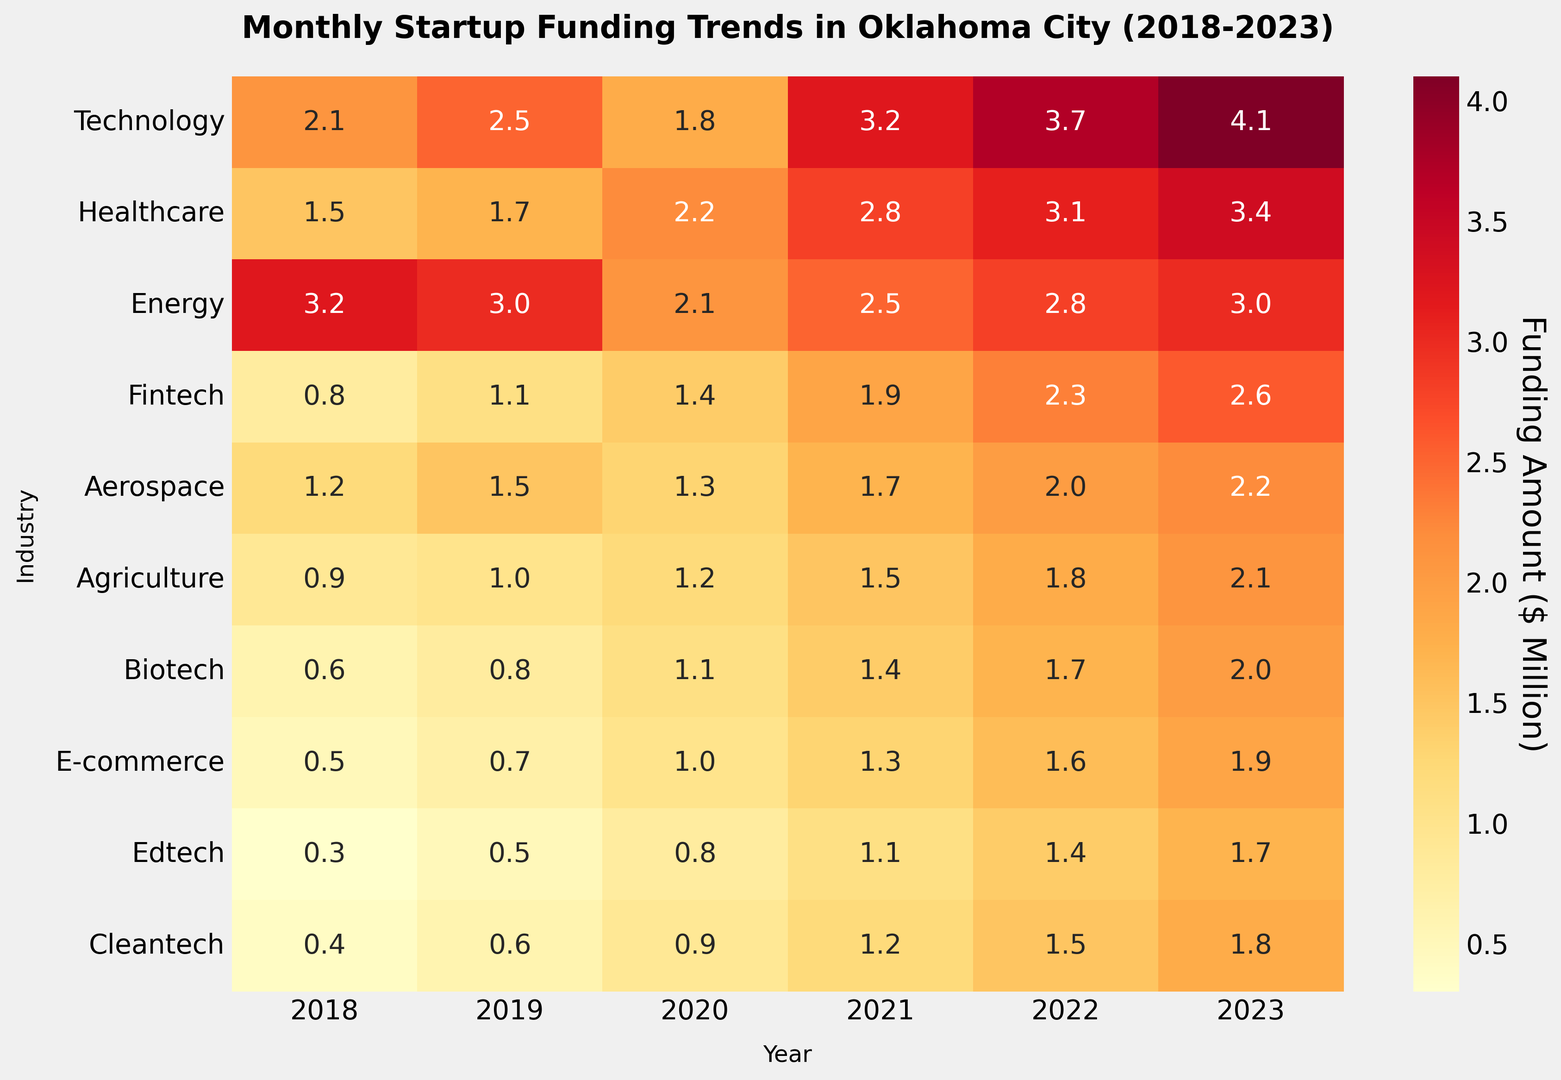What's the trend in funding for the Technology industry from 2018 to 2023? The Technology industry's funding increases over the years from 2.1 million in 2018 to 4.1 million in 2023. The heatmap has increasingly darker shades of red, indicating higher values.
Answer: An increasing trend Which industry showed the most significant growth in funding from 2018 to 2023? Compare the difference in funding for each industry from 2018 to 2023. The Technology industry leads with 4.1 - 2.1 = 2.0 million increase, the largest growth among all industries.
Answer: Technology In which year was the funding for the Energy industry the lowest? By observing the heatmap and identifying the lightest shade of red in the Energy row, the funding was the lowest in 2020, with 2.1 million.
Answer: 2020 What is the combined funding for Biotech and Agriculture industries in 2023? Sum the 2023 funding amounts for Biotech (2.0 million) and Agriculture (2.1 million): 2.0 + 2.1 = 4.1 million.
Answer: 4.1 million Was there any year when Edtech and Cleantech industries had the same funding level? Compare the funding for Edtech and Cleantech across each year. In 2019, both had funding of 0.5 million.
Answer: 2019 How does the funding trend for Fintech compare to Aerospace from 2018 to 2023? Fintech shows a steady increase from 0.8 million in 2018 to 2.6 million in 2023, while Aerospace funding rises from 1.2 million in 2018 to 2.2 million in 2023, showing slower growth compared to Fintech.
Answer: Fintech grew faster Which year had the highest total funding across all industries? Summarize the funding amounts for all industries per year and compare: 
2018: 12.5 million
2019: 13.4 million
2020: 12.8 million
2021: 16.6 million
2022: 20.9 million
2023: 23.8 million
2023 had the highest total funding.
Answer: 2023 What is the average funding for the Healthcare industry over the 5 years? Sum the funding amounts for Healthcare across the years and divide by 5: (1.5 + 1.7 + 2.2 + 2.8 + 3.1 + 3.4) / 6 = 2.45 million.
Answer: 2.45 million 